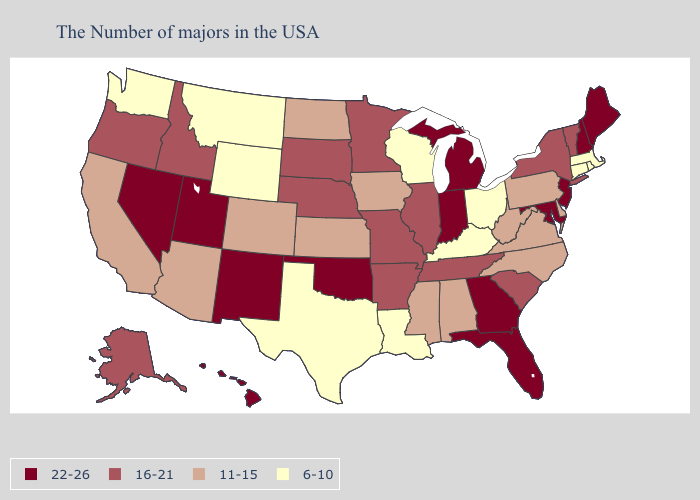What is the lowest value in the USA?
Answer briefly. 6-10. What is the highest value in states that border Wisconsin?
Short answer required. 22-26. Does New York have the same value as California?
Give a very brief answer. No. What is the value of Illinois?
Keep it brief. 16-21. Among the states that border Colorado , which have the highest value?
Be succinct. Oklahoma, New Mexico, Utah. Name the states that have a value in the range 11-15?
Keep it brief. Delaware, Pennsylvania, Virginia, North Carolina, West Virginia, Alabama, Mississippi, Iowa, Kansas, North Dakota, Colorado, Arizona, California. What is the highest value in states that border Michigan?
Write a very short answer. 22-26. Name the states that have a value in the range 22-26?
Answer briefly. Maine, New Hampshire, New Jersey, Maryland, Florida, Georgia, Michigan, Indiana, Oklahoma, New Mexico, Utah, Nevada, Hawaii. Does the first symbol in the legend represent the smallest category?
Answer briefly. No. Among the states that border Maine , which have the highest value?
Short answer required. New Hampshire. What is the lowest value in states that border West Virginia?
Quick response, please. 6-10. What is the value of New Mexico?
Short answer required. 22-26. Does the first symbol in the legend represent the smallest category?
Quick response, please. No. Does the map have missing data?
Keep it brief. No. What is the value of Arizona?
Write a very short answer. 11-15. 